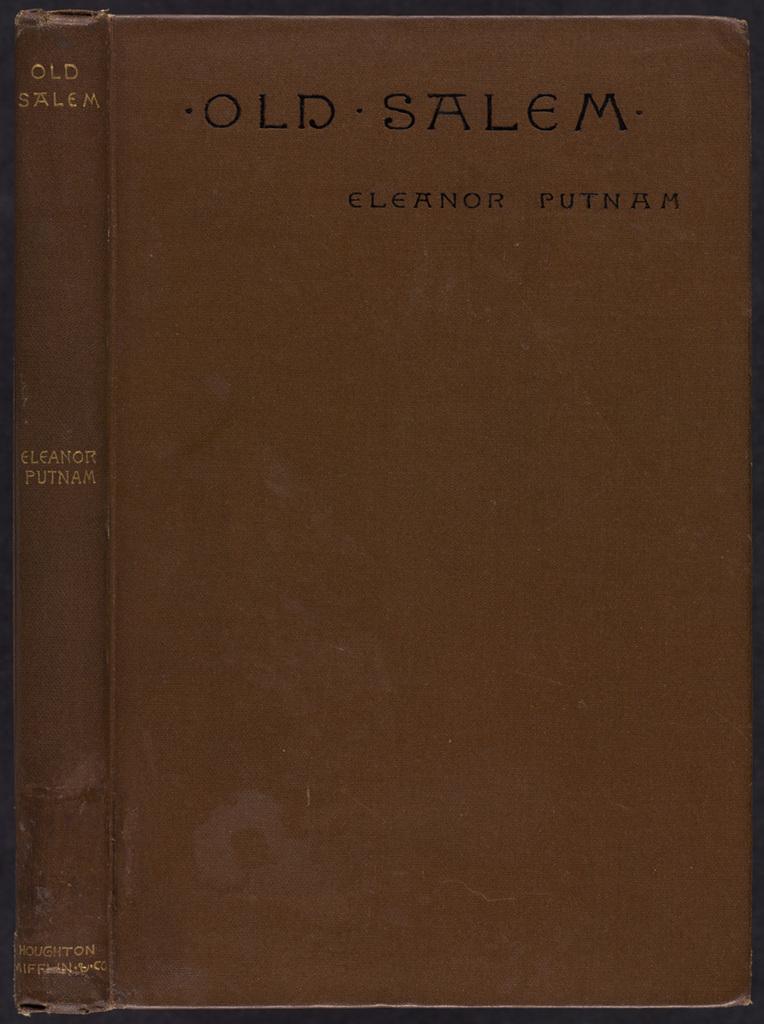Who wrote old salem?
Give a very brief answer. Eleanor putnam. What is the title of this book?
Offer a very short reply. Old salem. 